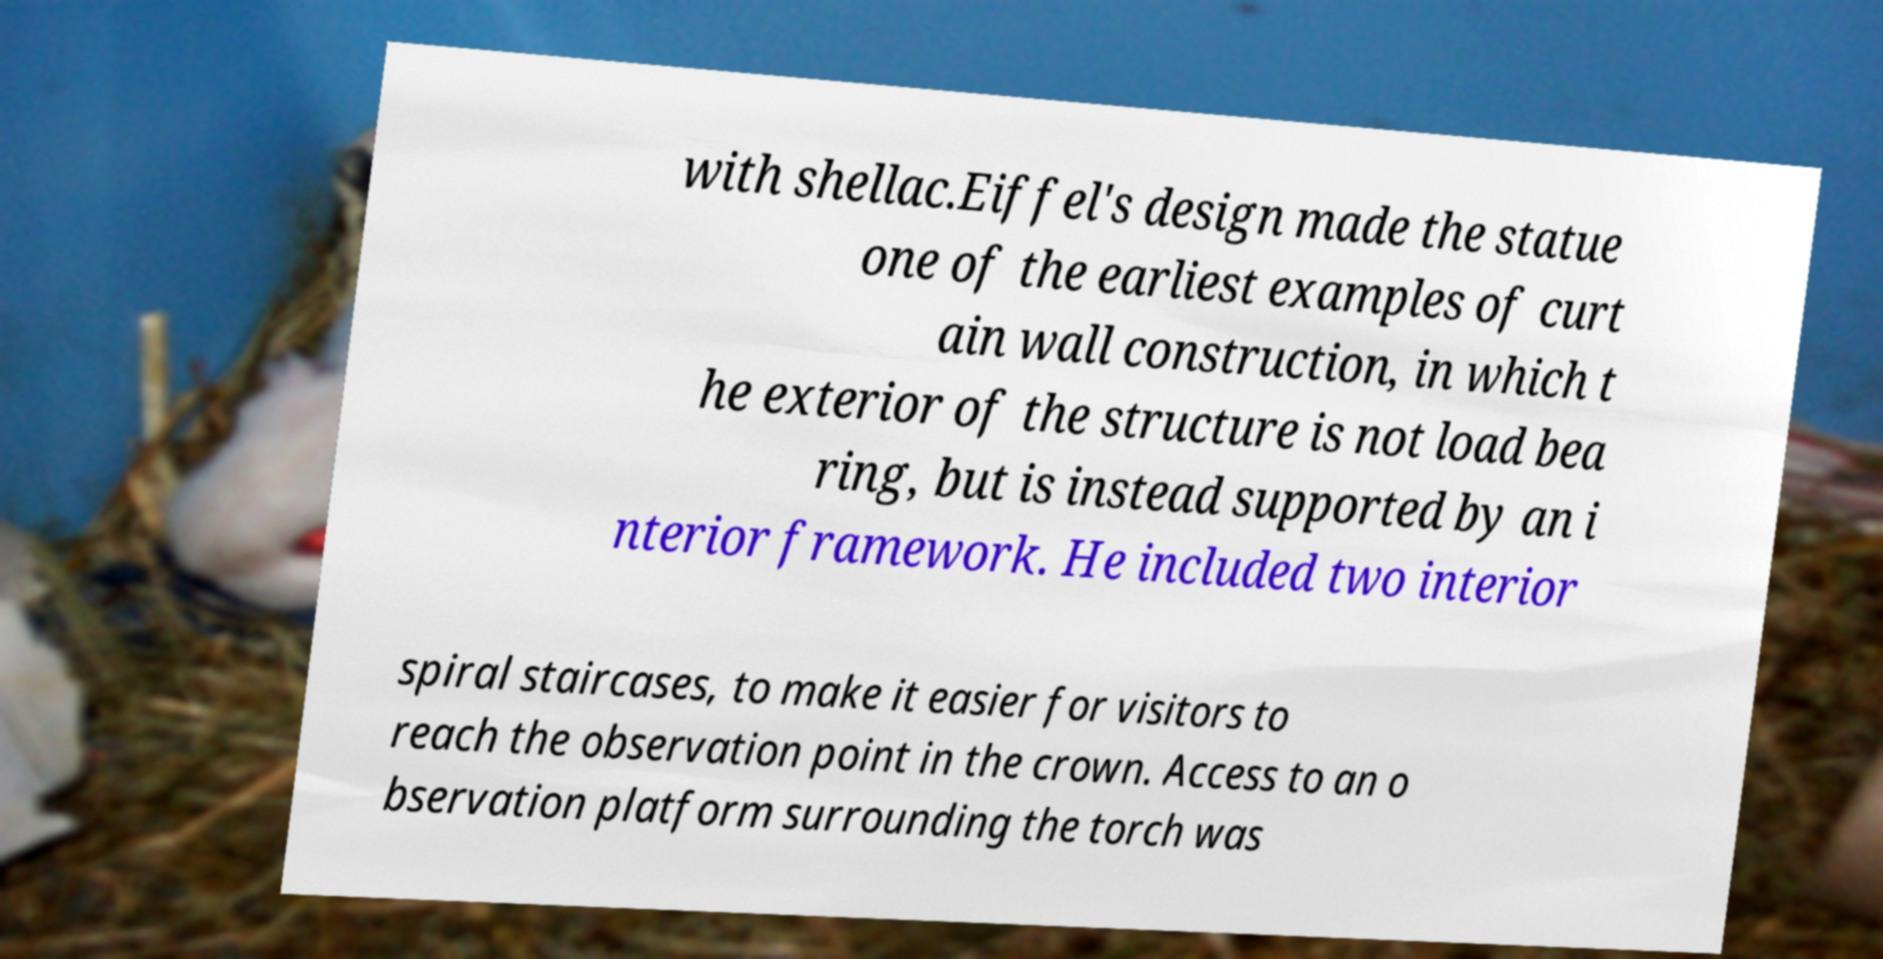There's text embedded in this image that I need extracted. Can you transcribe it verbatim? with shellac.Eiffel's design made the statue one of the earliest examples of curt ain wall construction, in which t he exterior of the structure is not load bea ring, but is instead supported by an i nterior framework. He included two interior spiral staircases, to make it easier for visitors to reach the observation point in the crown. Access to an o bservation platform surrounding the torch was 